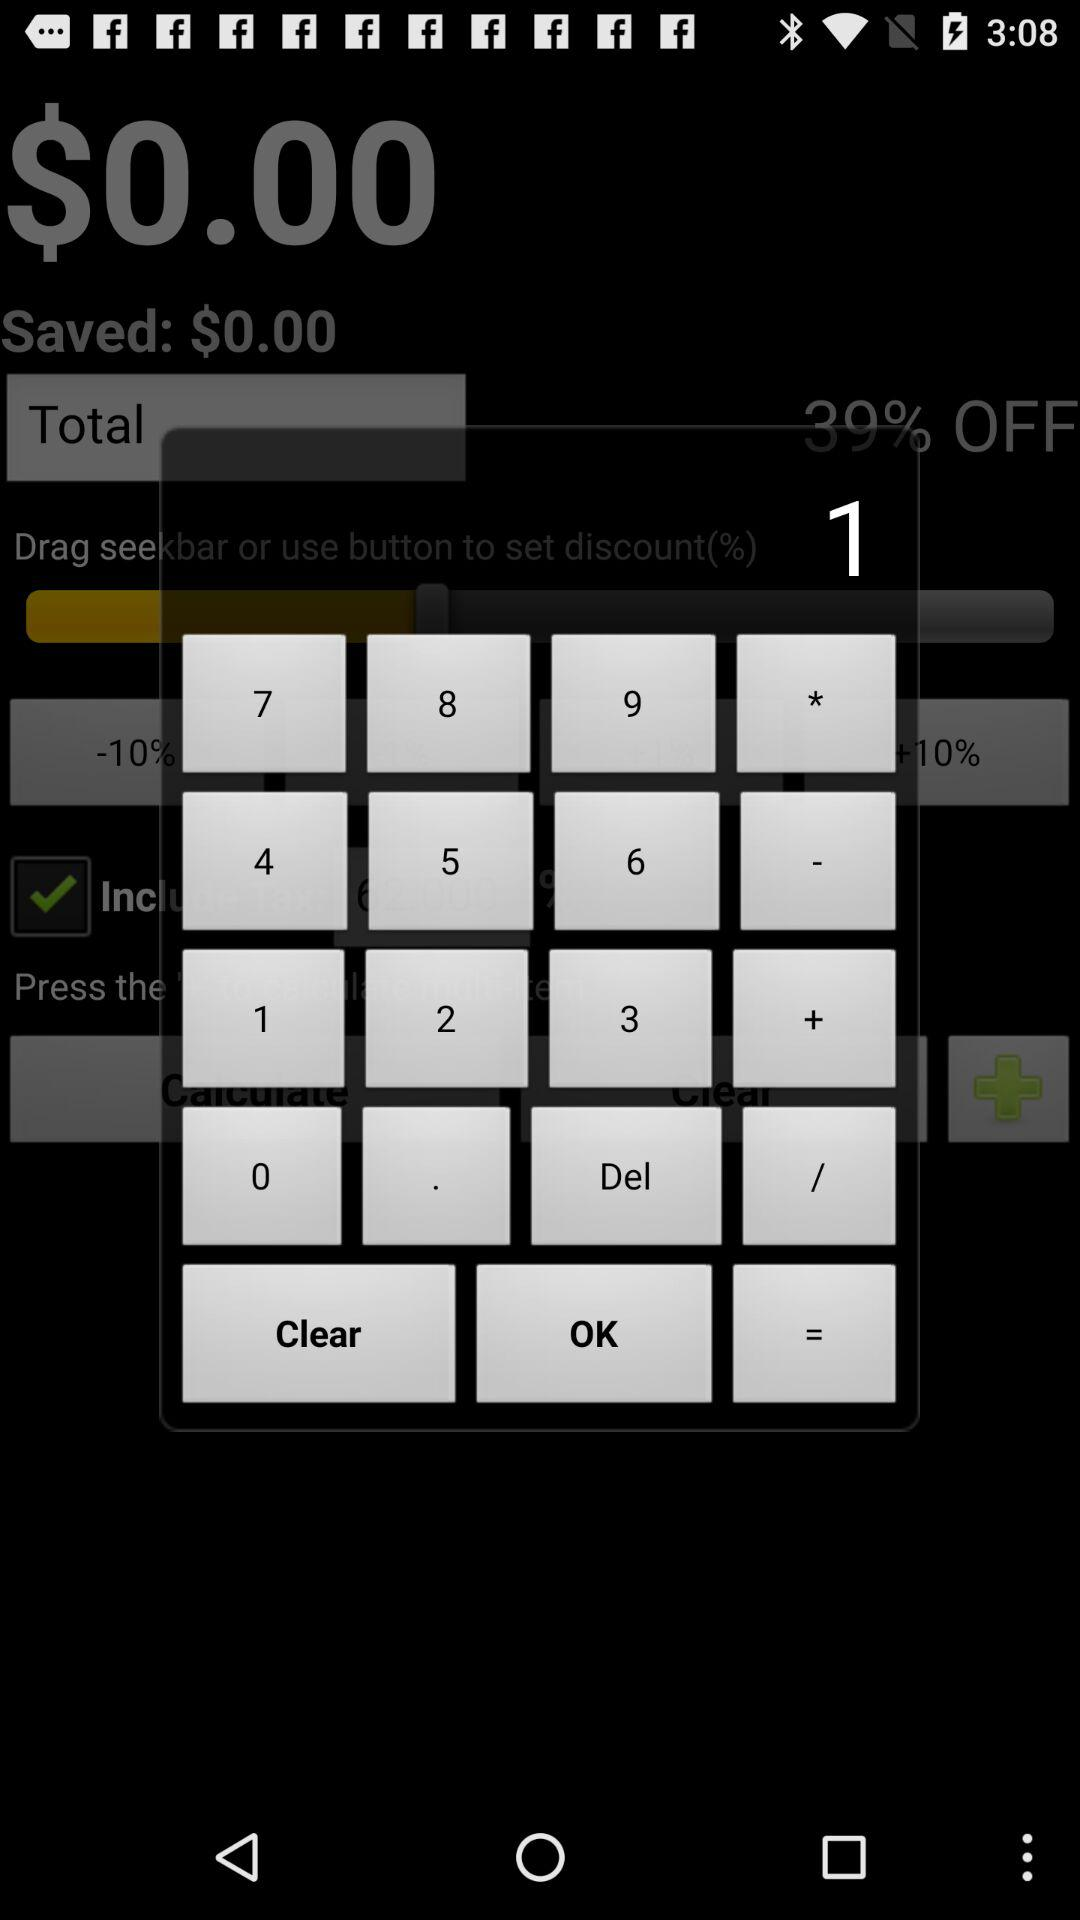What is the difference between the total and saved amount?
Answer the question using a single word or phrase. $0.00 